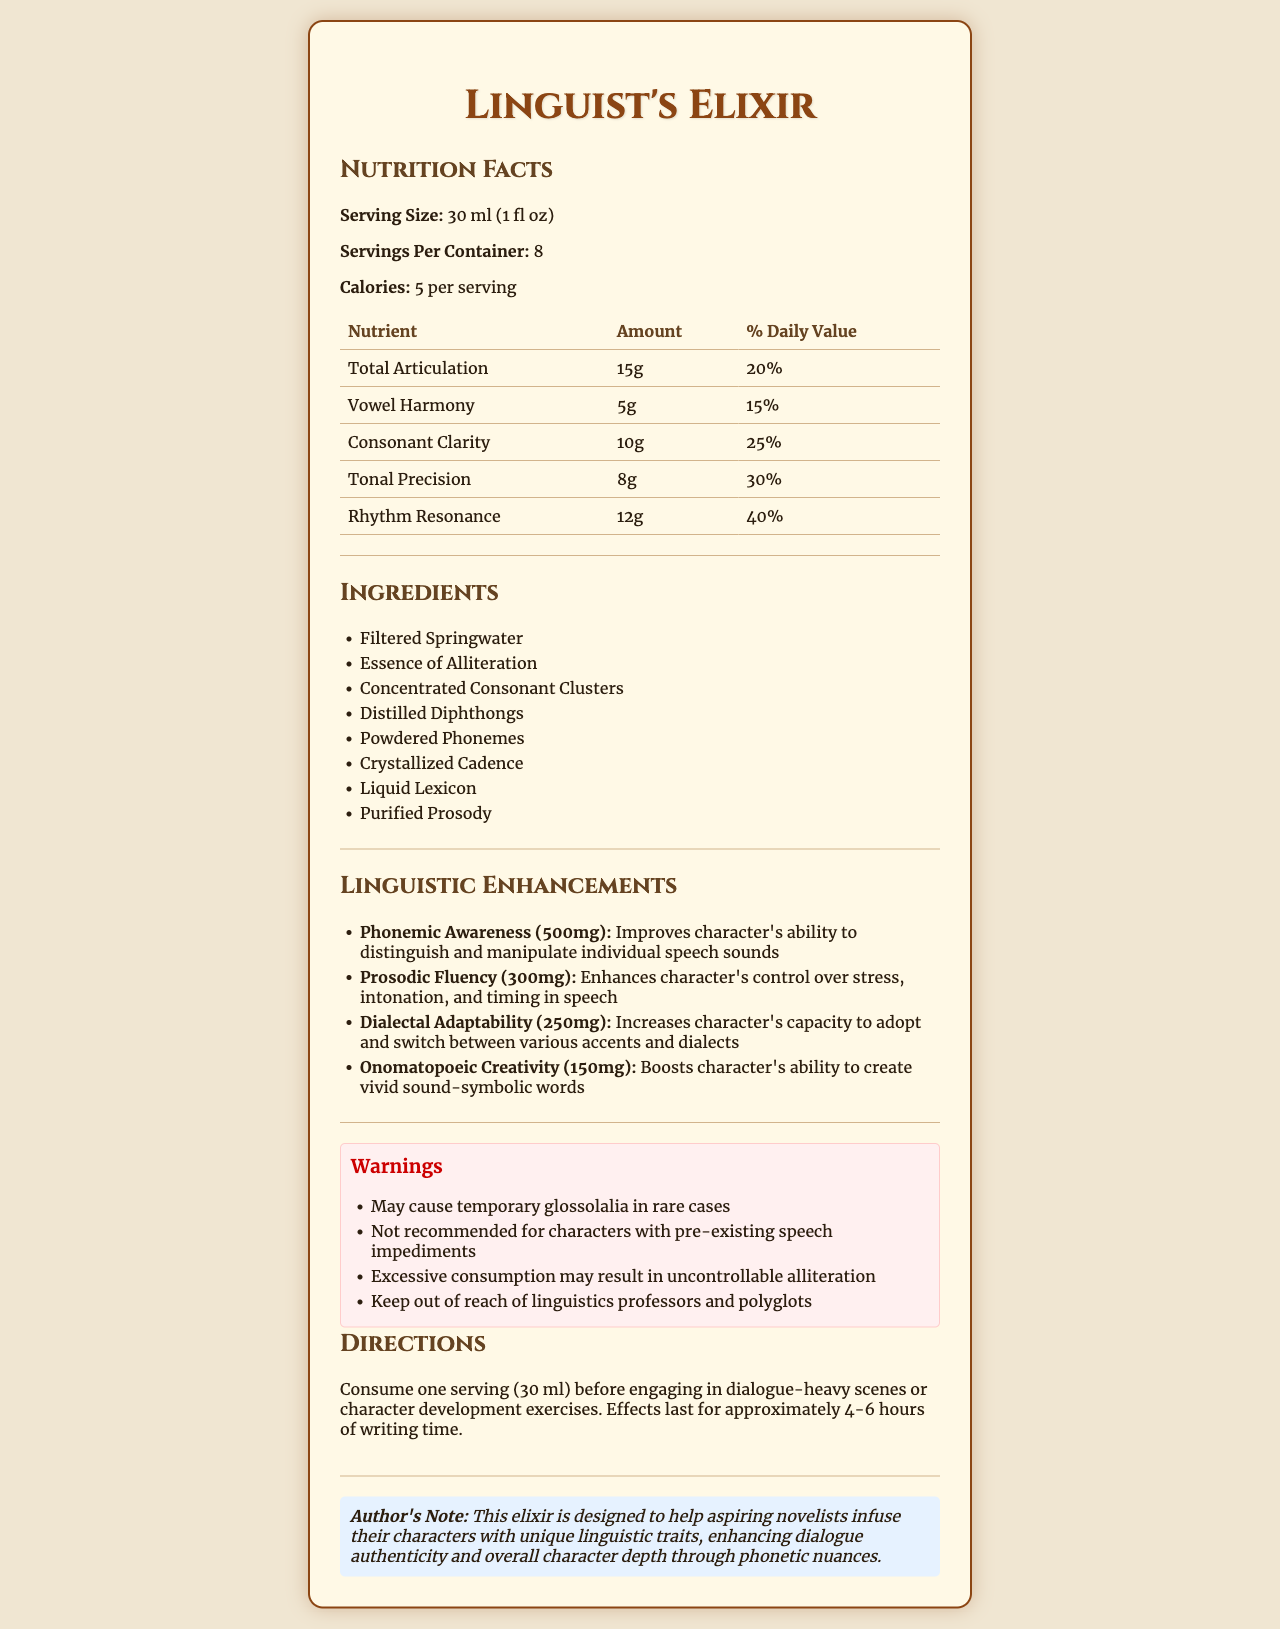what is the serving size? The serving size is listed at the top section of the nutrition facts as "Serving Size: 30 ml (1 fl oz)".
Answer: 30 ml (1 fl oz) how many calories are there per serving? The calories per serving are mentioned in the nutrition facts section with a value of 5 calories per serving.
Answer: 5 calories list the first three ingredients of the Linguist's Elixir. The ingredients are detailed in a list, and the first three mentioned are "Filtered Springwater," "Essence of Alliteration," and "Concentrated Consonant Clusters."
Answer: Filtered Springwater, Essence of Alliteration, Concentrated Consonant Clusters what is the amount of dialectal adaptability in the potion? Under the linguistic enhancements section, Dialectal Adaptability is stated to have an amount of 250mg.
Answer: 250mg how should this elixir be consumed for best results? The directions for consumption are clearly stated under the "Directions" section.
Answer: Consume one serving (30 ml) before engaging in dialogue-heavy scenes or character development exercises. Effects last for approximately 4-6 hours of writing time. what health warning is given about existing speech impediments? The warnings section includes a specific note: "Not recommended for characters with pre-existing speech impediments."
Answer: Not recommended for characters with pre-existing speech impediments what might happen if one consumes excessive amounts of this elixir? A. Enhanced creativity B. Uncontrollable alliteration C. Improved memory D. Temporary muteness The warning section notes specifically: "Excessive consumption may result in uncontrollable alliteration."
Answer: B. Uncontrollable alliteration which of the following is not a nutrient listed in the potion's nutrition facts? I. Total Articulation II. Vowel Harmony III. Onomatopoeic Creativity IV. Tonal Precision Onomatopoeic Creativity is listed under linguistic enhancements but not under the nutrition facts. The others (Total Articulation, Vowel Harmony, and Tonal Precision) are listed in the nutrition facts.
Answer: III. Onomatopoeic Creativity does the elixir contain any calories? The nutrition facts state that there are 5 calories per serving.
Answer: Yes summarize the purpose and properties of the Linguist's Elixir. The summary captures the main idea of the potion, its components, intended use, and benefits along with potential warnings.
Answer: The Linguist's Elixir is a potion designed to enhance linguistic abilities, such as phonemic awareness, prosodic fluency, and dialectal adaptability, in characters. It has both nutrition facts indicating components like Total Articulation and Vowel Harmony, and comes with warnings about potential side effects. It assists aspiring novelists in developing authentic dialogue and character depth. who is advised to be cautious with this elixir? The warning section humorously advises to "Keep out of reach of linguistics professors and polyglots."
Answer: Linguistics professors and polyglots how long do the effects of this elixir generally last? The directions state that the effects last for about 4-6 hours of writing time.
Answer: Approximately 4-6 hours of writing time what is the total percentage of daily value for consonant clarity in one serving? The nutrition facts list Consonant Clarity with a daily value of 25%.
Answer: 25% what language family does this elixir help you learn? The document does not specify any particular language family that the elixir helps with; rather, it provides general enhancements across linguistic abilities.
Answer: Cannot be determined 